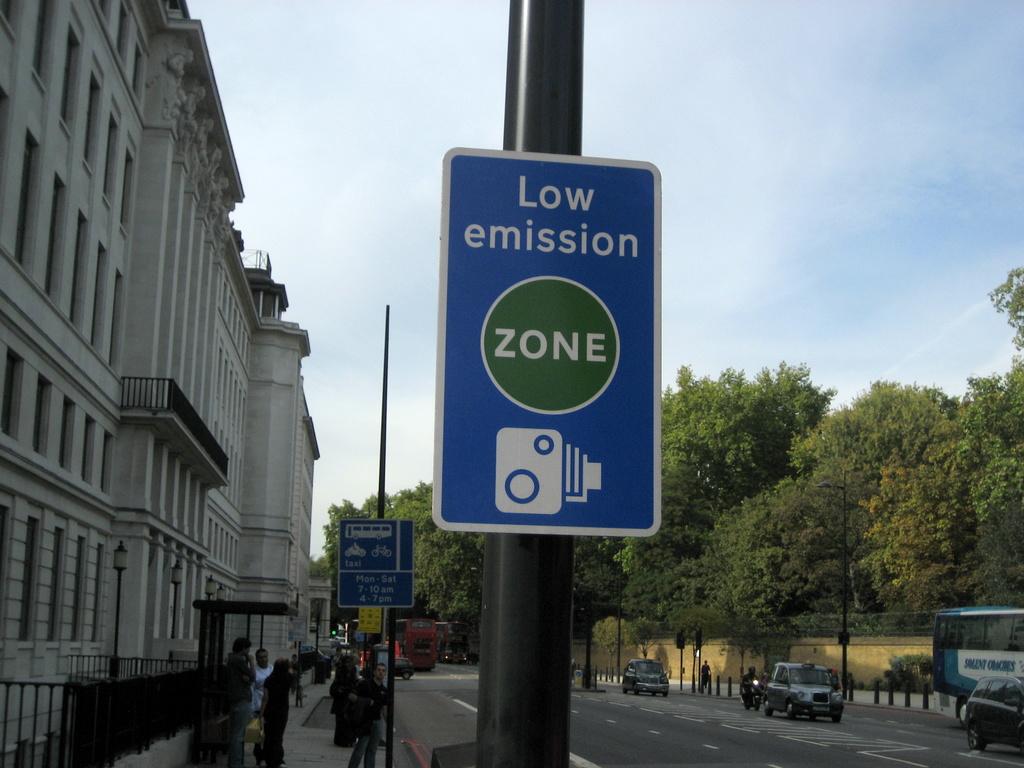What does the sign say?
Keep it short and to the point. Low emission zone. 